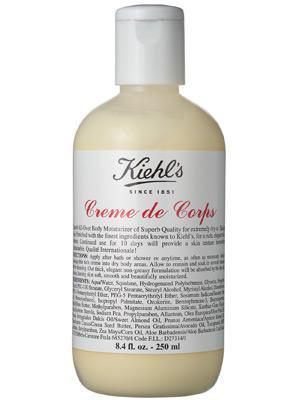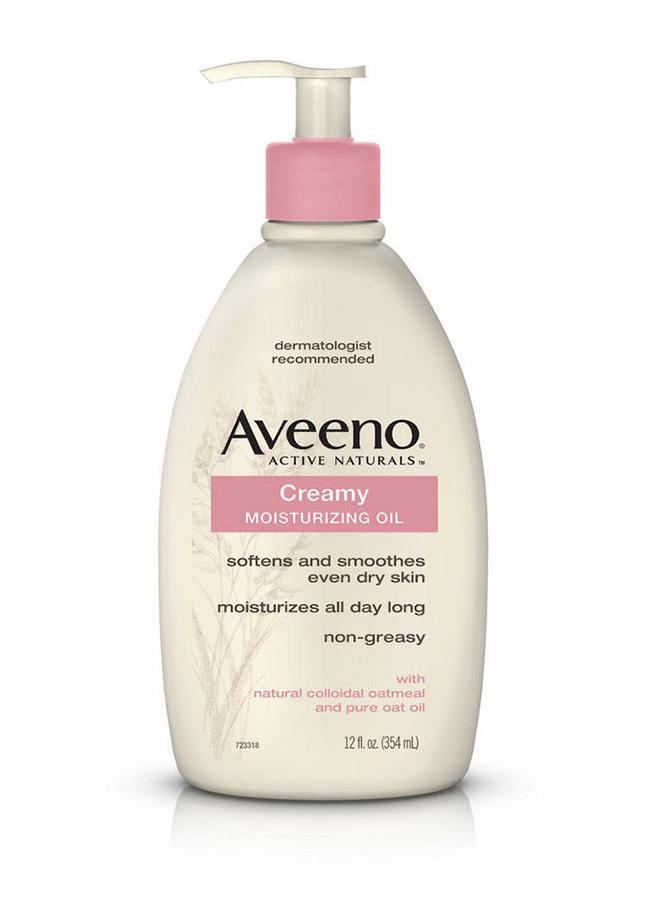The first image is the image on the left, the second image is the image on the right. Given the left and right images, does the statement "One of the bottles has a pump dispenser on top." hold true? Answer yes or no. Yes. The first image is the image on the left, the second image is the image on the right. Examine the images to the left and right. Is the description "One of the bottles has a pump cap." accurate? Answer yes or no. Yes. 